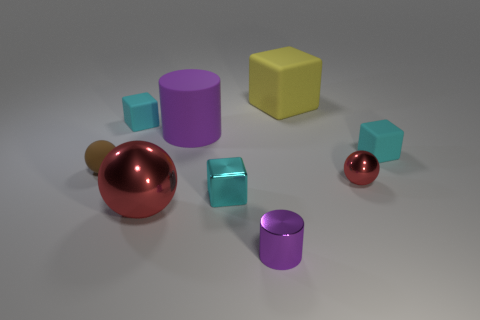Subtract all cyan cylinders. How many cyan blocks are left? 3 Subtract all yellow cubes. How many cubes are left? 3 Subtract all green cubes. Subtract all gray cylinders. How many cubes are left? 4 Add 1 metallic cylinders. How many objects exist? 10 Subtract all cylinders. How many objects are left? 7 Add 1 yellow things. How many yellow things are left? 2 Add 2 blue things. How many blue things exist? 2 Subtract 0 blue blocks. How many objects are left? 9 Subtract all large green rubber balls. Subtract all cyan metal cubes. How many objects are left? 8 